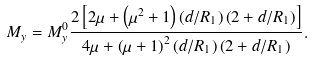<formula> <loc_0><loc_0><loc_500><loc_500>M _ { y } = M _ { y } ^ { 0 } \frac { 2 \left [ 2 \mu + \left ( \mu ^ { 2 } + 1 \right ) \left ( d / R _ { 1 } \right ) \left ( 2 + d / R _ { 1 } \right ) \right ] } { 4 \mu + \left ( \mu + 1 \right ) ^ { 2 } \left ( d / R _ { 1 } \right ) \left ( 2 + d / R _ { 1 } \right ) } .</formula> 